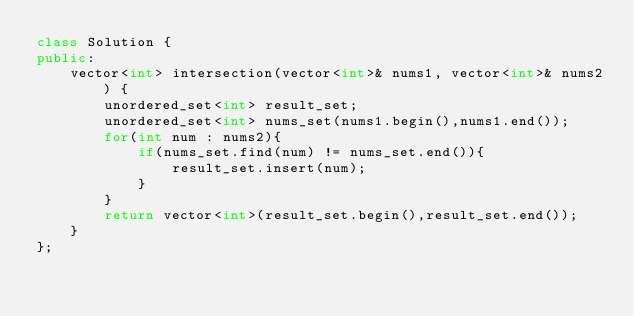<code> <loc_0><loc_0><loc_500><loc_500><_C++_>class Solution {
public:
    vector<int> intersection(vector<int>& nums1, vector<int>& nums2) {
        unordered_set<int> result_set;
        unordered_set<int> nums_set(nums1.begin(),nums1.end());
        for(int num : nums2){
            if(nums_set.find(num) != nums_set.end()){
                result_set.insert(num);
            }
        }
        return vector<int>(result_set.begin(),result_set.end());
    }
};</code> 